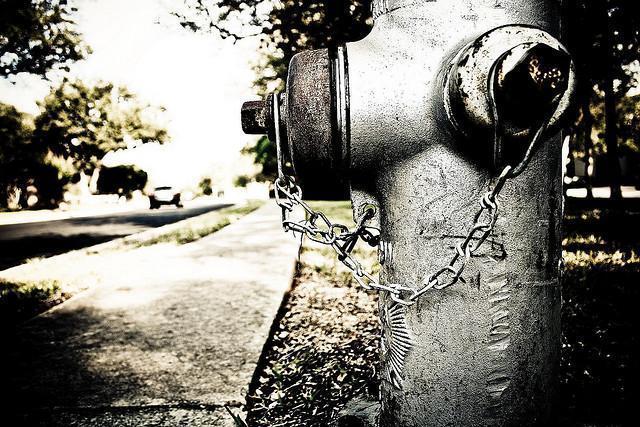How many people are in the background?
Give a very brief answer. 0. 